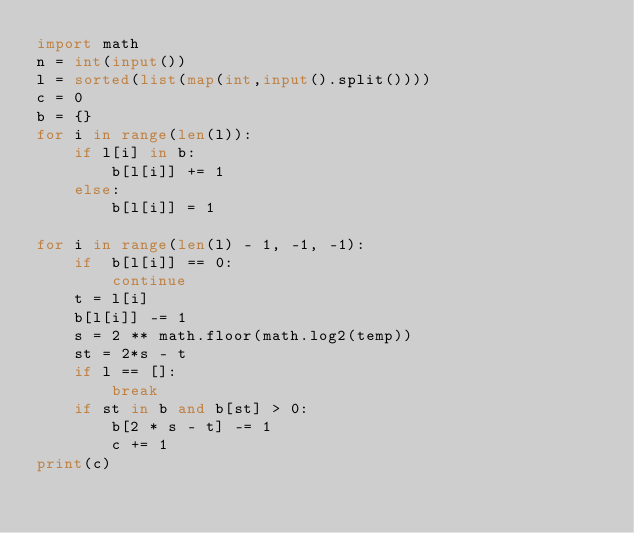Convert code to text. <code><loc_0><loc_0><loc_500><loc_500><_Python_>import math
n = int(input())
l = sorted(list(map(int,input().split())))
c = 0
b = {}
for i in range(len(l)):
    if l[i] in b:
        b[l[i]] += 1
    else:
        b[l[i]] = 1

for i in range(len(l) - 1, -1, -1):
    if  b[l[i]] == 0:
        continue
    t = l[i]
    b[l[i]] -= 1
    s = 2 ** math.floor(math.log2(temp))
    st = 2*s - t 
    if l == []:
        break
    if st in b and b[st] > 0:
        b[2 * s - t] -= 1
        c += 1
print(c)</code> 